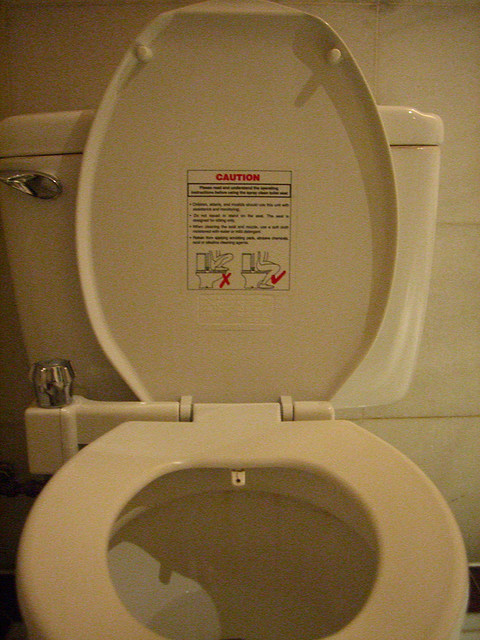Identify and read out the text in this image. CAUTION 